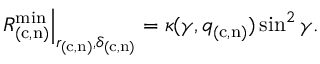Convert formula to latex. <formula><loc_0><loc_0><loc_500><loc_500>R _ { ( c , n ) } ^ { \min } \right | _ { r _ { ( c , n ) } , \delta _ { ( c , n ) } } = \kappa ( \gamma , q _ { ( c , n ) } ) \sin ^ { 2 } \gamma .</formula> 